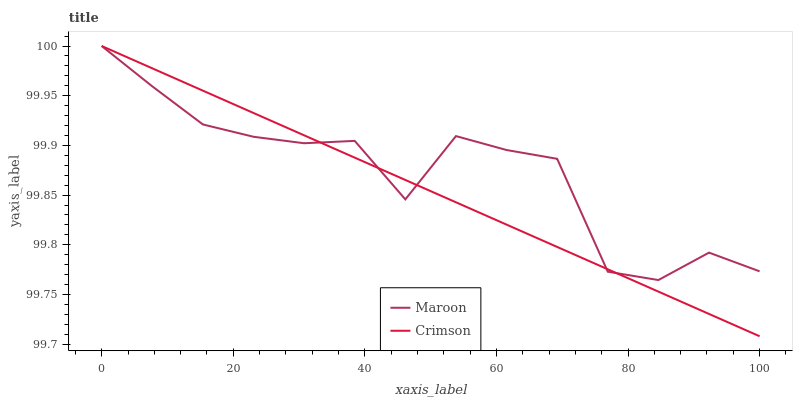Does Maroon have the minimum area under the curve?
Answer yes or no. No. Is Maroon the smoothest?
Answer yes or no. No. Does Maroon have the lowest value?
Answer yes or no. No. 